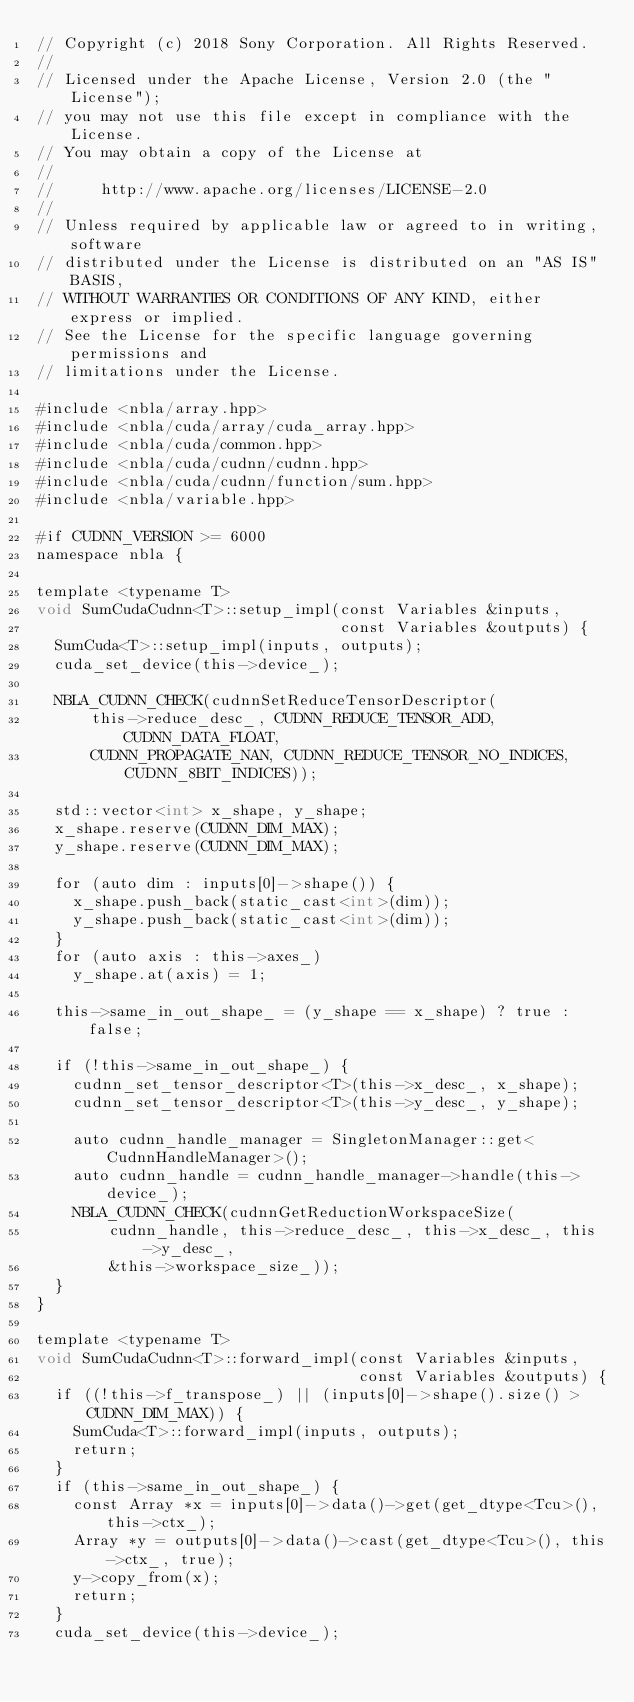<code> <loc_0><loc_0><loc_500><loc_500><_Cuda_>// Copyright (c) 2018 Sony Corporation. All Rights Reserved.
//
// Licensed under the Apache License, Version 2.0 (the "License");
// you may not use this file except in compliance with the License.
// You may obtain a copy of the License at
//
//     http://www.apache.org/licenses/LICENSE-2.0
//
// Unless required by applicable law or agreed to in writing, software
// distributed under the License is distributed on an "AS IS" BASIS,
// WITHOUT WARRANTIES OR CONDITIONS OF ANY KIND, either express or implied.
// See the License for the specific language governing permissions and
// limitations under the License.

#include <nbla/array.hpp>
#include <nbla/cuda/array/cuda_array.hpp>
#include <nbla/cuda/common.hpp>
#include <nbla/cuda/cudnn/cudnn.hpp>
#include <nbla/cuda/cudnn/function/sum.hpp>
#include <nbla/variable.hpp>

#if CUDNN_VERSION >= 6000
namespace nbla {

template <typename T>
void SumCudaCudnn<T>::setup_impl(const Variables &inputs,
                                 const Variables &outputs) {
  SumCuda<T>::setup_impl(inputs, outputs);
  cuda_set_device(this->device_);

  NBLA_CUDNN_CHECK(cudnnSetReduceTensorDescriptor(
      this->reduce_desc_, CUDNN_REDUCE_TENSOR_ADD, CUDNN_DATA_FLOAT,
      CUDNN_PROPAGATE_NAN, CUDNN_REDUCE_TENSOR_NO_INDICES, CUDNN_8BIT_INDICES));

  std::vector<int> x_shape, y_shape;
  x_shape.reserve(CUDNN_DIM_MAX);
  y_shape.reserve(CUDNN_DIM_MAX);

  for (auto dim : inputs[0]->shape()) {
    x_shape.push_back(static_cast<int>(dim));
    y_shape.push_back(static_cast<int>(dim));
  }
  for (auto axis : this->axes_)
    y_shape.at(axis) = 1;

  this->same_in_out_shape_ = (y_shape == x_shape) ? true : false;

  if (!this->same_in_out_shape_) {
    cudnn_set_tensor_descriptor<T>(this->x_desc_, x_shape);
    cudnn_set_tensor_descriptor<T>(this->y_desc_, y_shape);

    auto cudnn_handle_manager = SingletonManager::get<CudnnHandleManager>();
    auto cudnn_handle = cudnn_handle_manager->handle(this->device_);
    NBLA_CUDNN_CHECK(cudnnGetReductionWorkspaceSize(
        cudnn_handle, this->reduce_desc_, this->x_desc_, this->y_desc_,
        &this->workspace_size_));
  }
}

template <typename T>
void SumCudaCudnn<T>::forward_impl(const Variables &inputs,
                                   const Variables &outputs) {
  if ((!this->f_transpose_) || (inputs[0]->shape().size() > CUDNN_DIM_MAX)) {
    SumCuda<T>::forward_impl(inputs, outputs);
    return;
  }
  if (this->same_in_out_shape_) {
    const Array *x = inputs[0]->data()->get(get_dtype<Tcu>(), this->ctx_);
    Array *y = outputs[0]->data()->cast(get_dtype<Tcu>(), this->ctx_, true);
    y->copy_from(x);
    return;
  }
  cuda_set_device(this->device_);</code> 